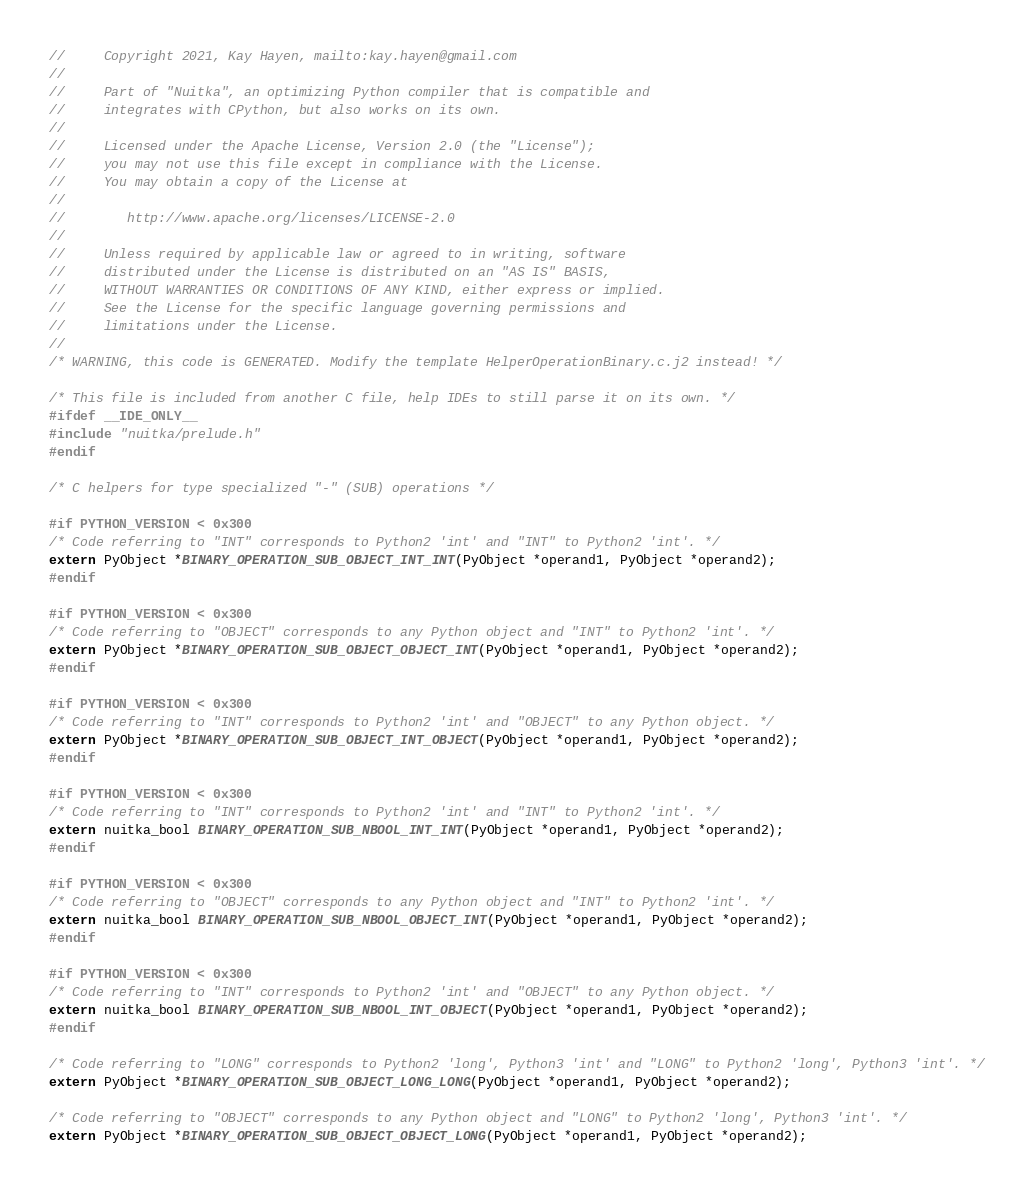Convert code to text. <code><loc_0><loc_0><loc_500><loc_500><_C_>//     Copyright 2021, Kay Hayen, mailto:kay.hayen@gmail.com
//
//     Part of "Nuitka", an optimizing Python compiler that is compatible and
//     integrates with CPython, but also works on its own.
//
//     Licensed under the Apache License, Version 2.0 (the "License");
//     you may not use this file except in compliance with the License.
//     You may obtain a copy of the License at
//
//        http://www.apache.org/licenses/LICENSE-2.0
//
//     Unless required by applicable law or agreed to in writing, software
//     distributed under the License is distributed on an "AS IS" BASIS,
//     WITHOUT WARRANTIES OR CONDITIONS OF ANY KIND, either express or implied.
//     See the License for the specific language governing permissions and
//     limitations under the License.
//
/* WARNING, this code is GENERATED. Modify the template HelperOperationBinary.c.j2 instead! */

/* This file is included from another C file, help IDEs to still parse it on its own. */
#ifdef __IDE_ONLY__
#include "nuitka/prelude.h"
#endif

/* C helpers for type specialized "-" (SUB) operations */

#if PYTHON_VERSION < 0x300
/* Code referring to "INT" corresponds to Python2 'int' and "INT" to Python2 'int'. */
extern PyObject *BINARY_OPERATION_SUB_OBJECT_INT_INT(PyObject *operand1, PyObject *operand2);
#endif

#if PYTHON_VERSION < 0x300
/* Code referring to "OBJECT" corresponds to any Python object and "INT" to Python2 'int'. */
extern PyObject *BINARY_OPERATION_SUB_OBJECT_OBJECT_INT(PyObject *operand1, PyObject *operand2);
#endif

#if PYTHON_VERSION < 0x300
/* Code referring to "INT" corresponds to Python2 'int' and "OBJECT" to any Python object. */
extern PyObject *BINARY_OPERATION_SUB_OBJECT_INT_OBJECT(PyObject *operand1, PyObject *operand2);
#endif

#if PYTHON_VERSION < 0x300
/* Code referring to "INT" corresponds to Python2 'int' and "INT" to Python2 'int'. */
extern nuitka_bool BINARY_OPERATION_SUB_NBOOL_INT_INT(PyObject *operand1, PyObject *operand2);
#endif

#if PYTHON_VERSION < 0x300
/* Code referring to "OBJECT" corresponds to any Python object and "INT" to Python2 'int'. */
extern nuitka_bool BINARY_OPERATION_SUB_NBOOL_OBJECT_INT(PyObject *operand1, PyObject *operand2);
#endif

#if PYTHON_VERSION < 0x300
/* Code referring to "INT" corresponds to Python2 'int' and "OBJECT" to any Python object. */
extern nuitka_bool BINARY_OPERATION_SUB_NBOOL_INT_OBJECT(PyObject *operand1, PyObject *operand2);
#endif

/* Code referring to "LONG" corresponds to Python2 'long', Python3 'int' and "LONG" to Python2 'long', Python3 'int'. */
extern PyObject *BINARY_OPERATION_SUB_OBJECT_LONG_LONG(PyObject *operand1, PyObject *operand2);

/* Code referring to "OBJECT" corresponds to any Python object and "LONG" to Python2 'long', Python3 'int'. */
extern PyObject *BINARY_OPERATION_SUB_OBJECT_OBJECT_LONG(PyObject *operand1, PyObject *operand2);
</code> 